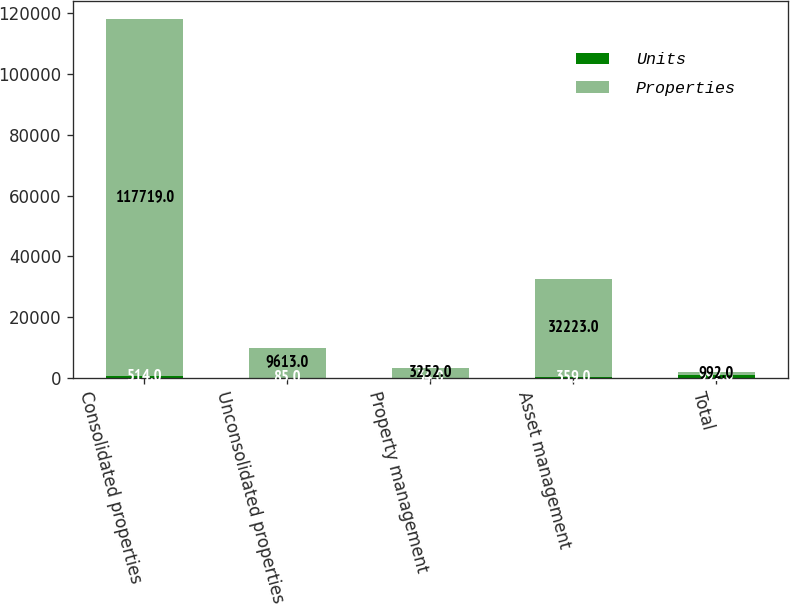Convert chart to OTSL. <chart><loc_0><loc_0><loc_500><loc_500><stacked_bar_chart><ecel><fcel>Consolidated properties<fcel>Unconsolidated properties<fcel>Property management<fcel>Asset management<fcel>Total<nl><fcel>Units<fcel>514<fcel>85<fcel>34<fcel>359<fcel>992<nl><fcel>Properties<fcel>117719<fcel>9613<fcel>3252<fcel>32223<fcel>992<nl></chart> 